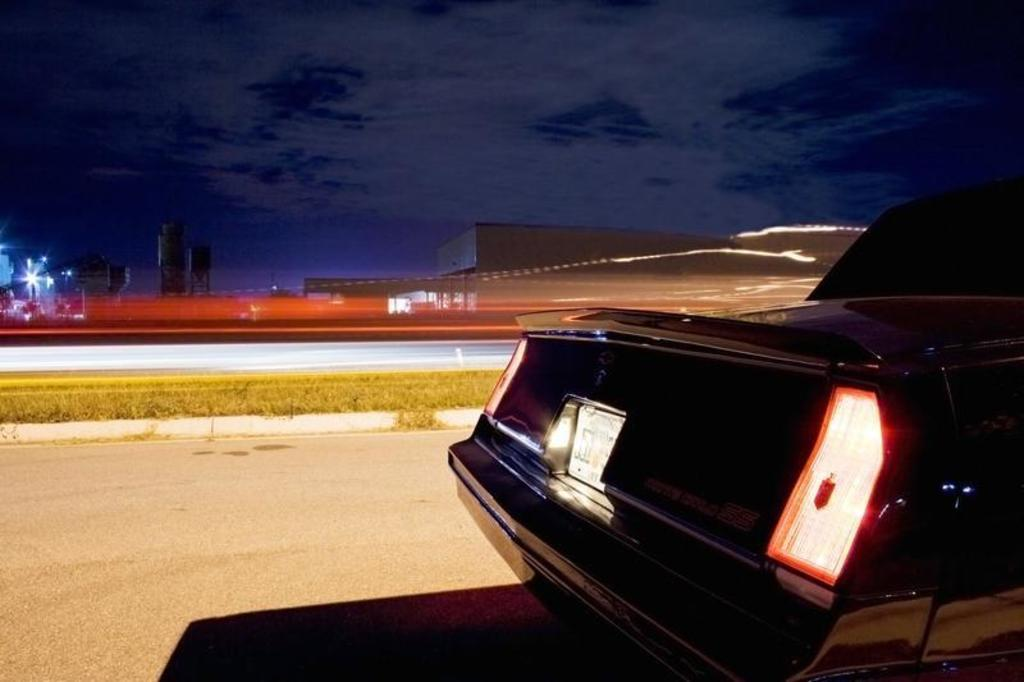What is the main subject of the image? There is a black car in the center of the image. Where is the car located? The car is on the road. What can be seen in the background of the image? There is sky, clouds, buildings, poles, lights, and grass visible in the background of the image. What type of bat is flying near the car in the image? There is no bat present in the image; it only features a black car on the road and various elements in the background. 